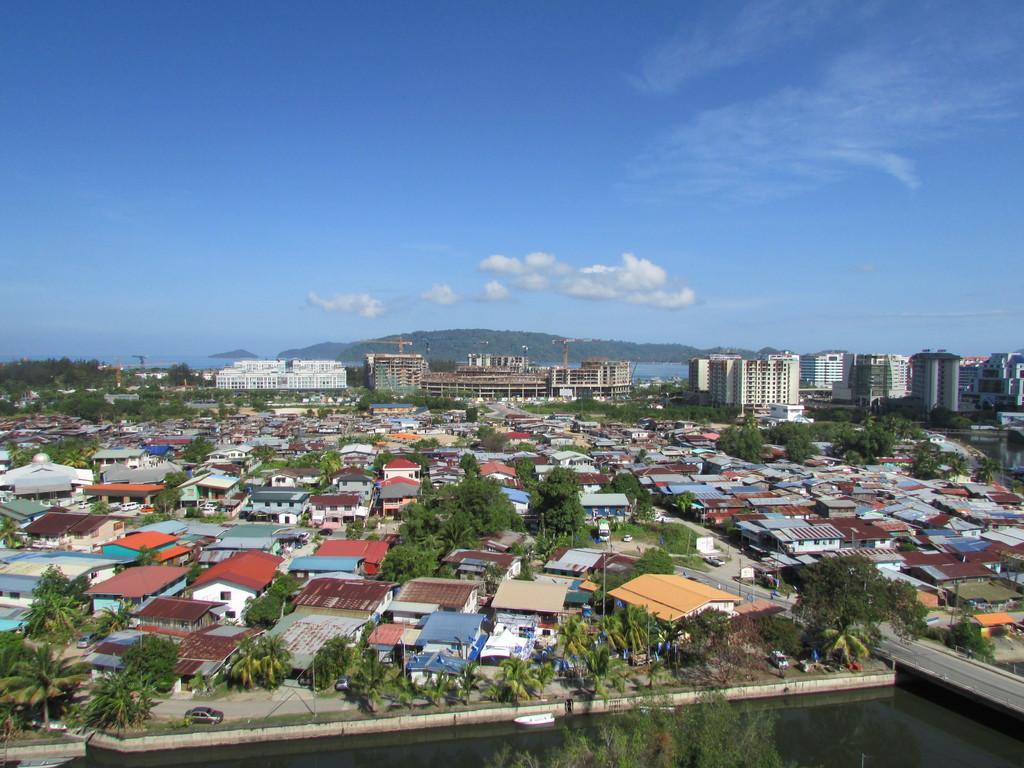What is the main subject of the image? The image provides an overview of a city. How would you describe the sky in the image? The sky is blue with little clouds. Can you identify any natural elements in the image? Water is present at the bottom of the image. How many giraffes can be seen in the image? There are no giraffes present in the image. What is the average income of the people living in the city shown in the image? The image does not provide information about the income of the people living in the city. 